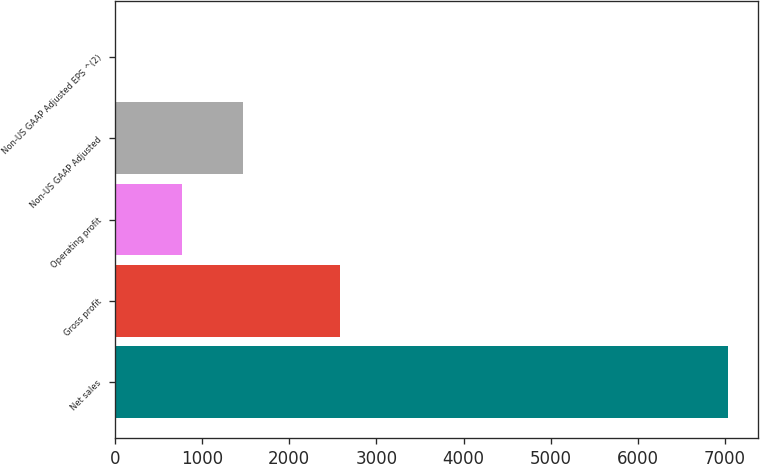Convert chart to OTSL. <chart><loc_0><loc_0><loc_500><loc_500><bar_chart><fcel>Net sales<fcel>Gross profit<fcel>Operating profit<fcel>Non-US GAAP Adjusted<fcel>Non-US GAAP Adjusted EPS ^(2)<nl><fcel>7031.5<fcel>2586.6<fcel>763.4<fcel>1466.29<fcel>2.59<nl></chart> 